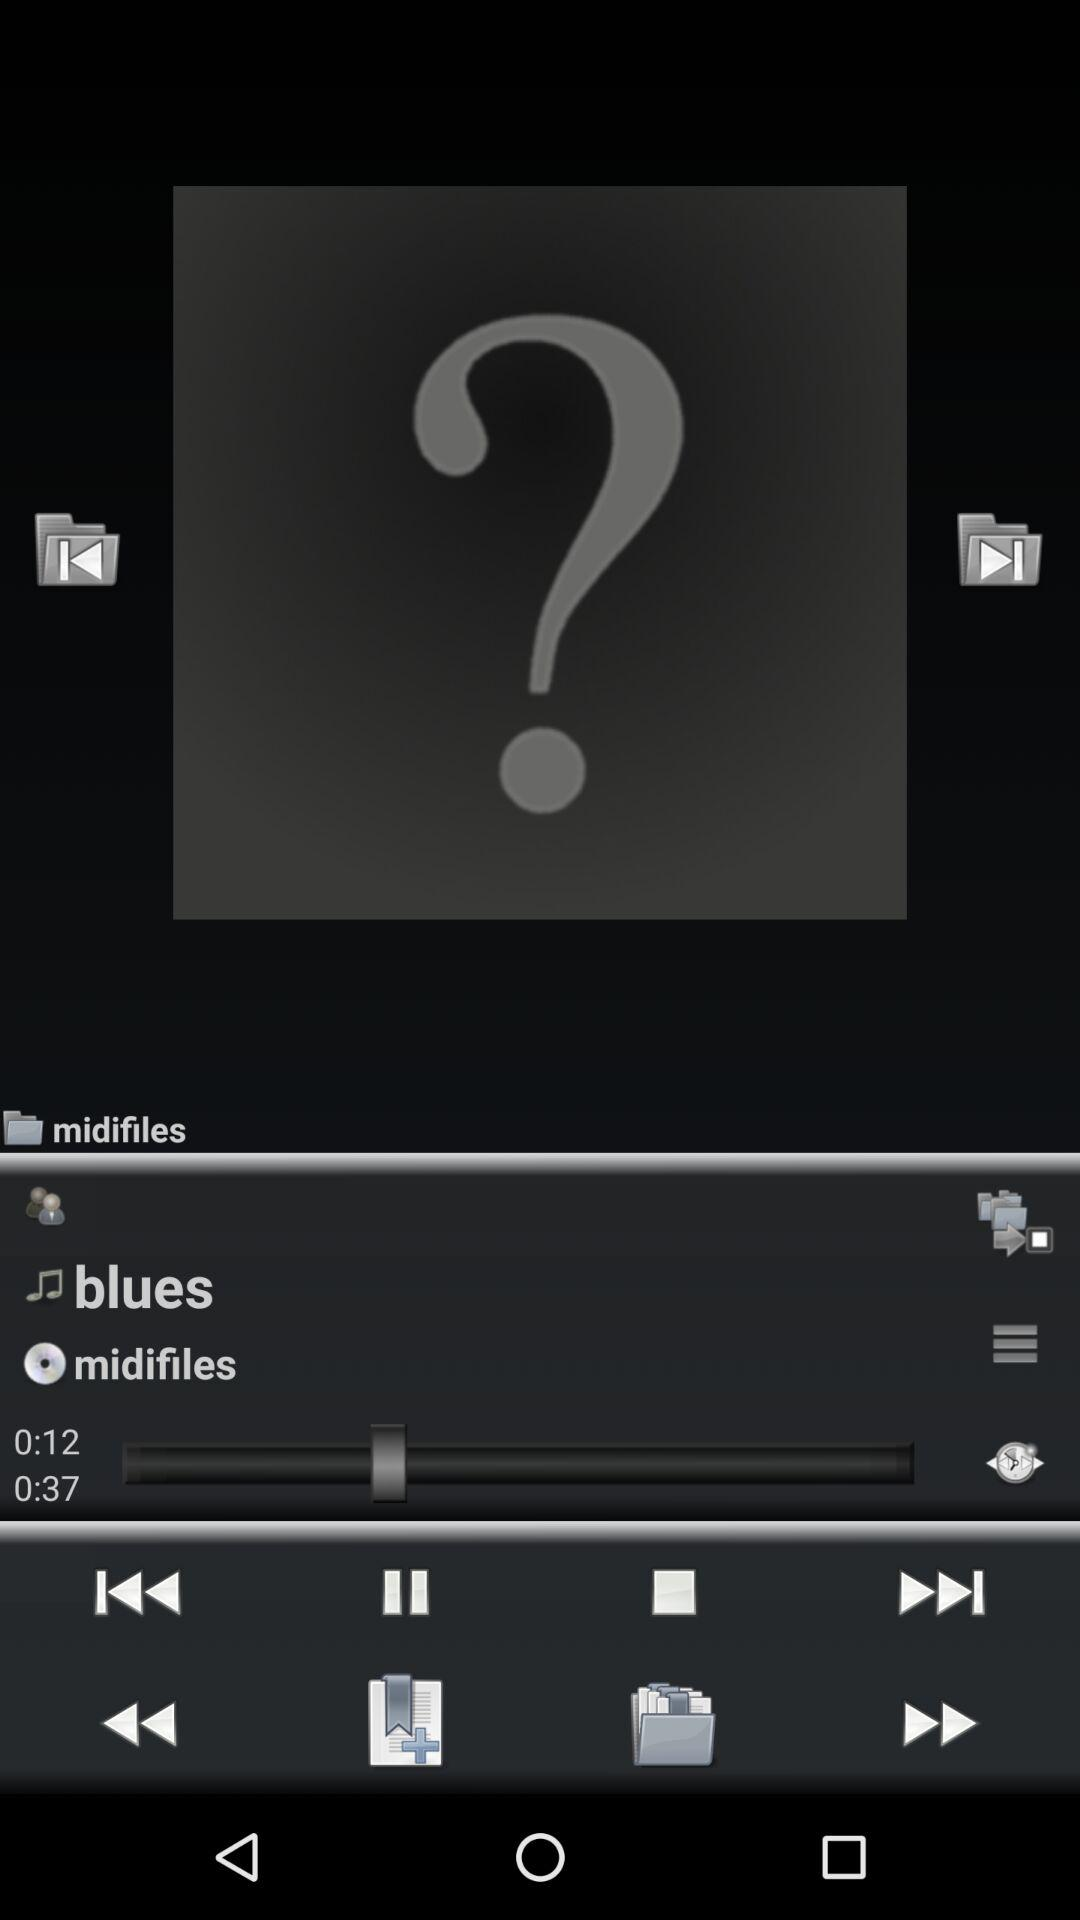How long has the song been played? The song is played up to 0:12. 